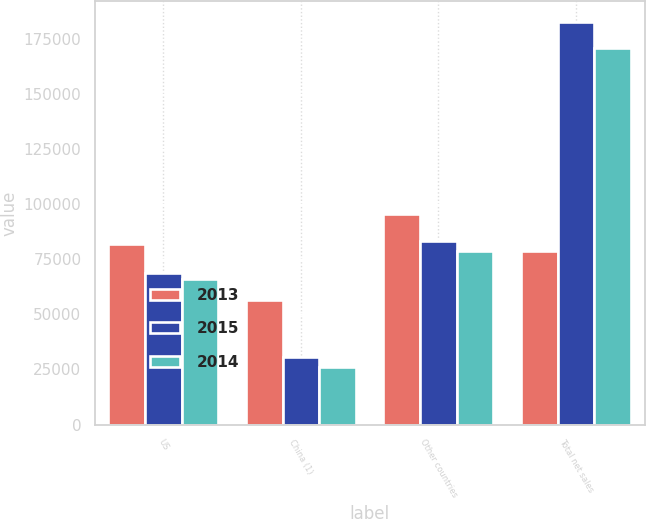<chart> <loc_0><loc_0><loc_500><loc_500><stacked_bar_chart><ecel><fcel>US<fcel>China (1)<fcel>Other countries<fcel>Total net sales<nl><fcel>2013<fcel>81732<fcel>56547<fcel>95436<fcel>78767<nl><fcel>2015<fcel>68909<fcel>30638<fcel>83248<fcel>182795<nl><fcel>2014<fcel>66197<fcel>25946<fcel>78767<fcel>170910<nl></chart> 